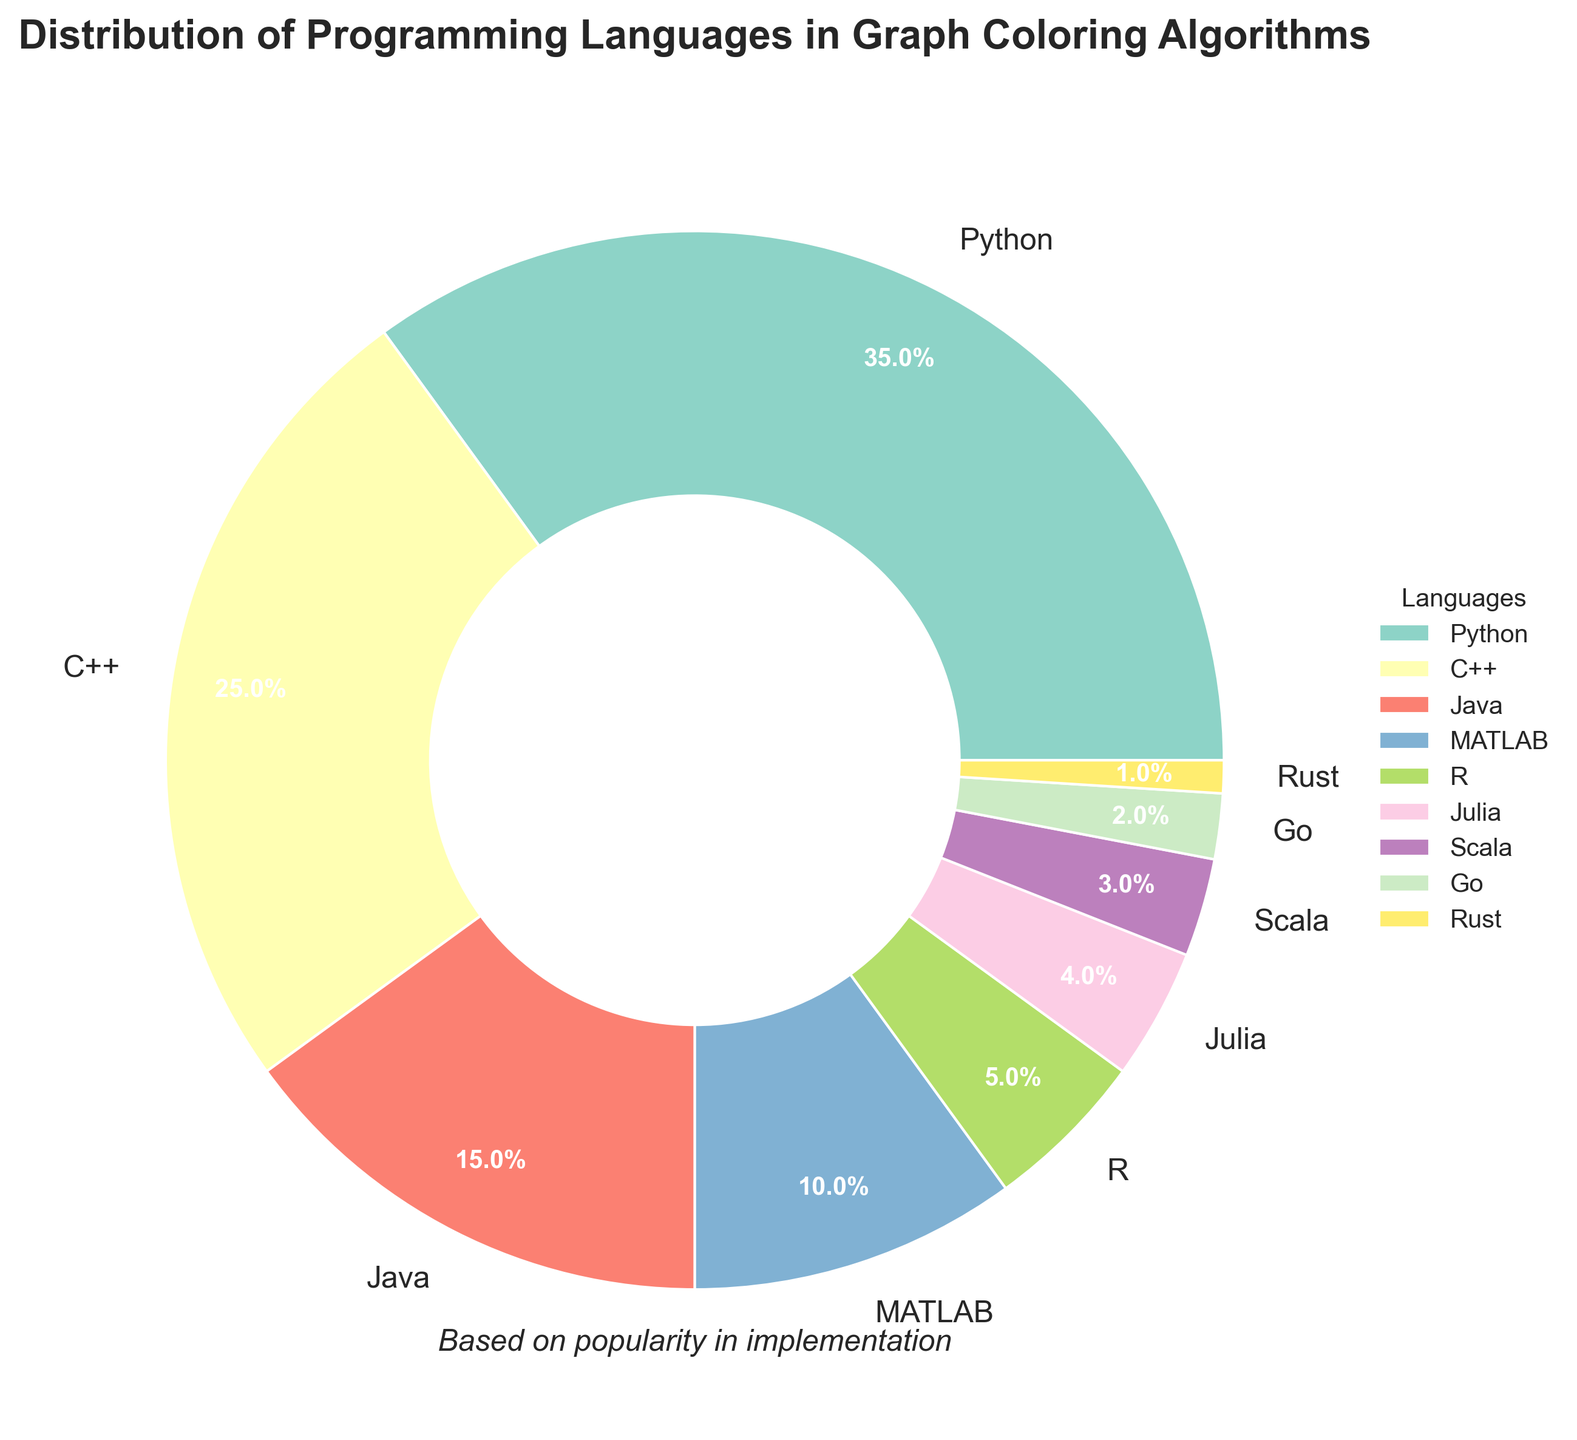Which programming language is the most popular for implementing graph coloring algorithms? The slice representing Python is the largest in the pie chart, indicating it is the most popular language used.
Answer: Python What is the combined percentage of Python and C++? The percentage for Python is 35% and for C++ is 25%. Adding these together, 35% + 25% = 60%.
Answer: 60% Which language has the smallest representation in the pie chart? The slice for Rust is the smallest, indicating it has the lowest percentage.
Answer: Rust How much more popular is Python compared to Java? Python has a 35% share, and Java has a 15% share. The difference is 35% - 15% = 20%.
Answer: 20% List the languages that have a representation of less than 5%. The languages with less than 5% are R (5%), Julia (4%), Scala (3%), Go (2%), and Rust (1%).
Answer: Julia, Scala, Go, Rust What is the percentage difference between MATLAB and R? MATLAB has 10%, and R has 5%. The difference is 10% - 5% = 5%.
Answer: 5% Rank the languages in decreasing order of their representation? The percentages are as follows: Python (35%), C++ (25%), Java (15%), MATLAB (10%), R (5%), Julia (4%), Scala (3%), Go (2%), Rust (1%). Ranking them in descending order: Python, C++, Java, MATLAB, R, Julia, Scala, Go, Rust.
Answer: Python, C++, Java, MATLAB, R, Julia, Scala, Go, Rust Which language group should be combined to account for more than 10% but less than 15%? Combining Julia (4%), Scala (3%), and Go (2%) gives 4% + 3% + 2% = 9%. Adding R (5%) to this group makes it a total of 14%.
Answer: Julia, Scala, Go, R What percentage of total usage do the bottom three languages account for? The bottom three languages are Go (2%) and Rust (1%). Adding these, 2% + 1% = 3%.
Answer: 3% 